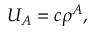Convert formula to latex. <formula><loc_0><loc_0><loc_500><loc_500>U _ { A } = c \rho ^ { A } ,</formula> 